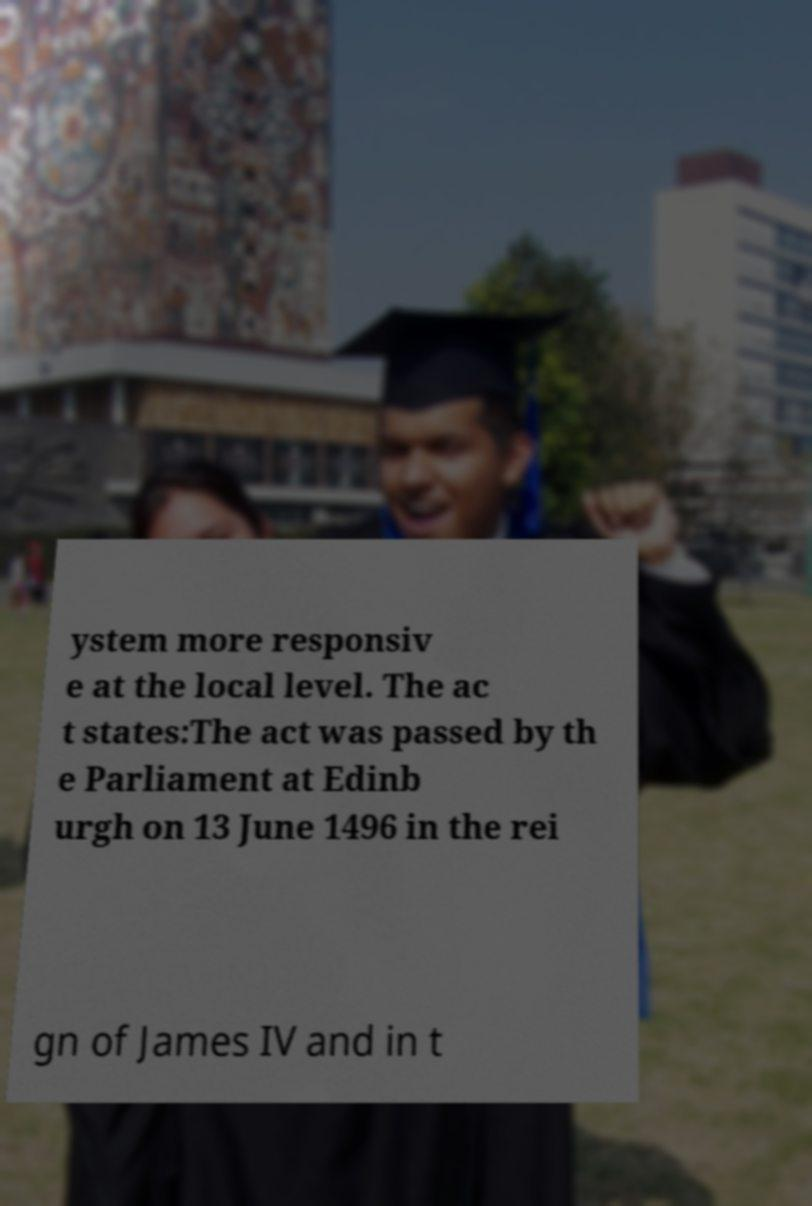Please identify and transcribe the text found in this image. ystem more responsiv e at the local level. The ac t states:The act was passed by th e Parliament at Edinb urgh on 13 June 1496 in the rei gn of James IV and in t 